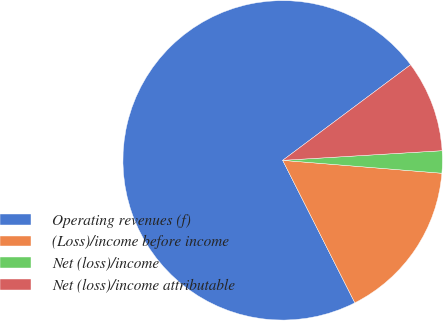Convert chart. <chart><loc_0><loc_0><loc_500><loc_500><pie_chart><fcel>Operating revenues (f)<fcel>(Loss)/income before income<fcel>Net (loss)/income<fcel>Net (loss)/income attributable<nl><fcel>72.25%<fcel>16.25%<fcel>2.25%<fcel>9.25%<nl></chart> 